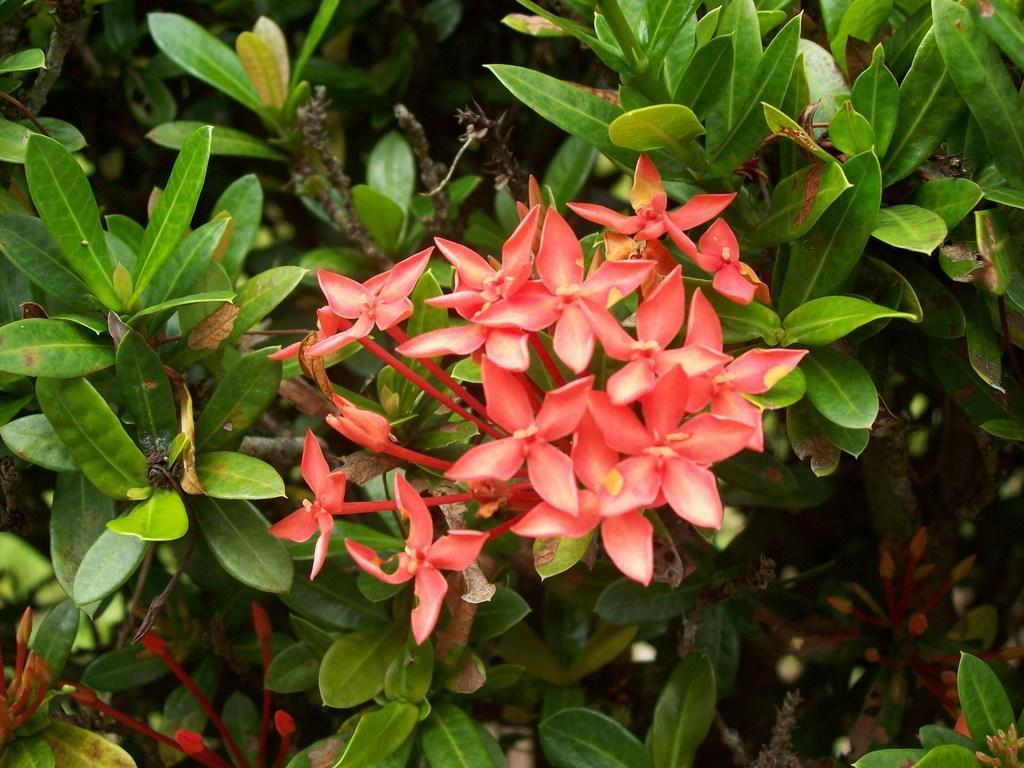How would you summarize this image in a sentence or two? In this picture we can see many orange flowers on the plant. In the bottom left corner we can see the birds. On the left we can see many leaves. 